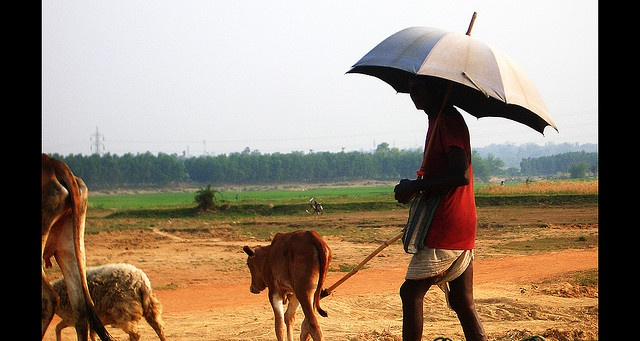Describe the objects in this image and their specific colors. I can see people in black, maroon, and brown tones, umbrella in black, ivory, tan, and gray tones, cow in black, maroon, and brown tones, cow in black, maroon, brown, and orange tones, and sheep in black, maroon, and brown tones in this image. 